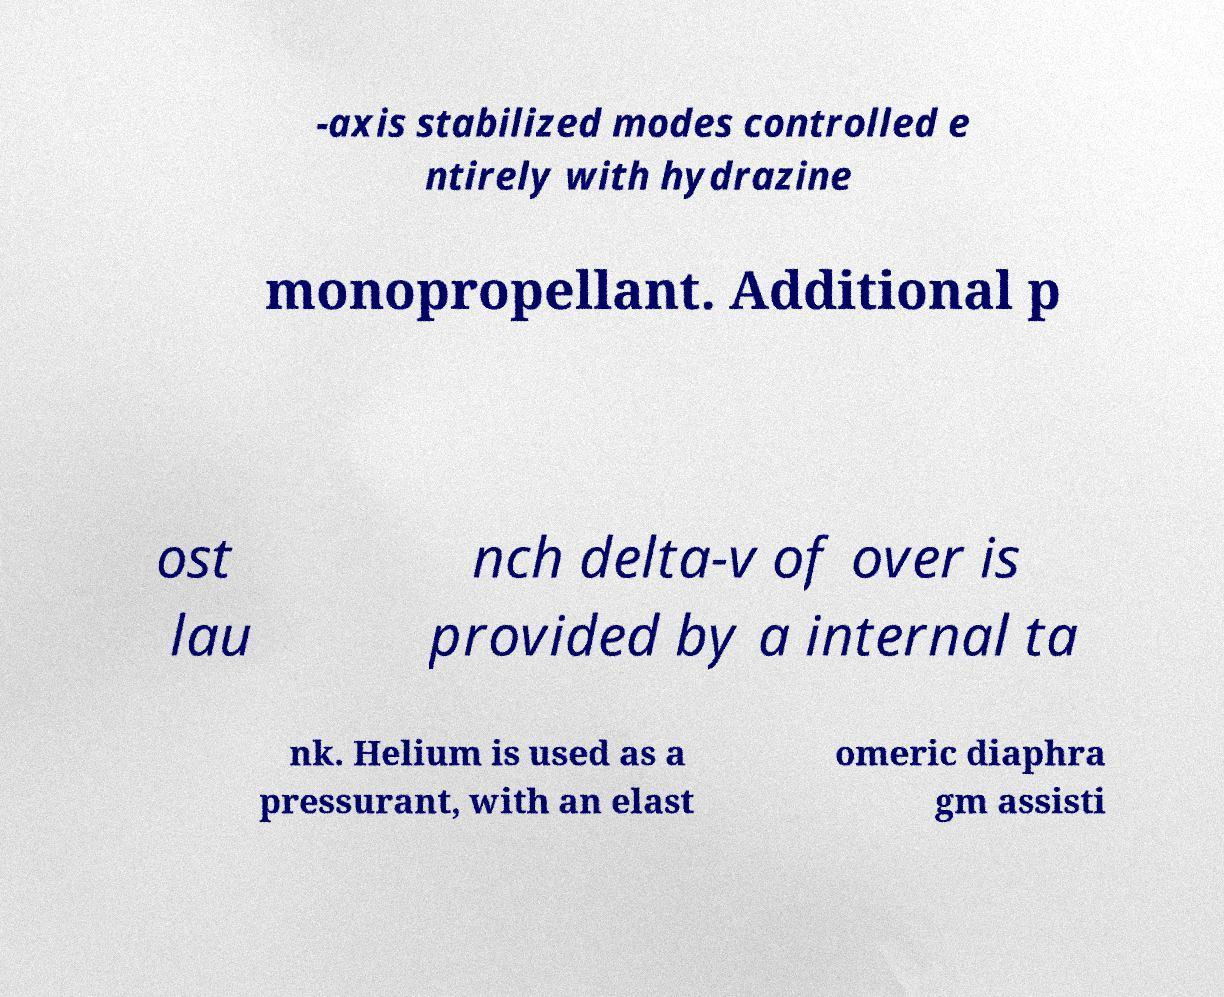Please read and relay the text visible in this image. What does it say? -axis stabilized modes controlled e ntirely with hydrazine monopropellant. Additional p ost lau nch delta-v of over is provided by a internal ta nk. Helium is used as a pressurant, with an elast omeric diaphra gm assisti 